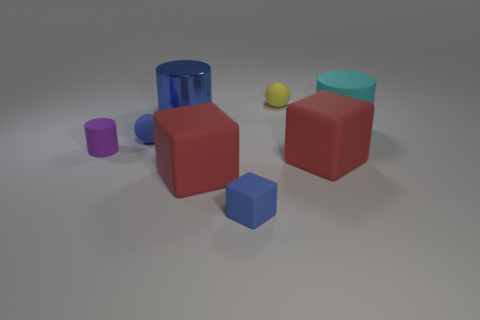There is a matte thing that is the same color as the small rubber block; what is its size?
Keep it short and to the point. Small. Are the large cyan cylinder and the large blue object made of the same material?
Your response must be concise. No. Are there any blue objects behind the tiny yellow rubber object that is right of the blue rubber object that is behind the tiny purple rubber cylinder?
Provide a succinct answer. No. Is the tiny block the same color as the large shiny cylinder?
Make the answer very short. Yes. Are there fewer big red cubes than cylinders?
Your answer should be compact. Yes. Is the material of the tiny blue object behind the purple rubber cylinder the same as the small thing that is in front of the tiny cylinder?
Provide a short and direct response. Yes. Is the number of blue shiny things that are behind the small yellow thing less than the number of small cyan shiny cubes?
Your response must be concise. No. What number of big blue shiny cylinders are to the right of the matte cylinder behind the purple matte object?
Ensure brevity in your answer.  0. What is the size of the cylinder that is both in front of the large metal cylinder and behind the blue ball?
Give a very brief answer. Large. Is there any other thing that has the same material as the large cyan object?
Your response must be concise. Yes. 